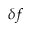<formula> <loc_0><loc_0><loc_500><loc_500>\delta f</formula> 